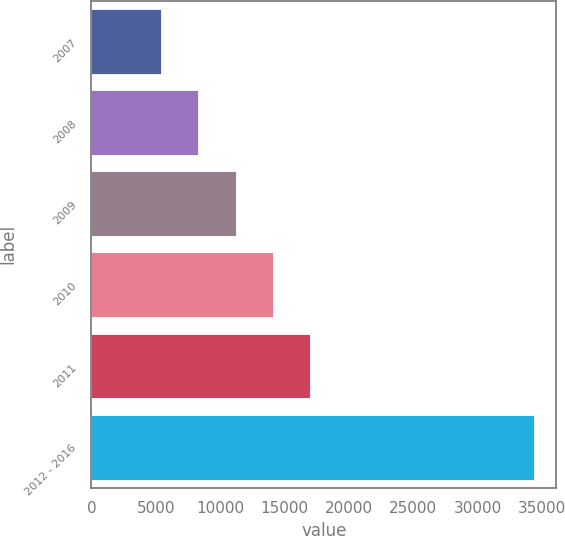Convert chart to OTSL. <chart><loc_0><loc_0><loc_500><loc_500><bar_chart><fcel>2007<fcel>2008<fcel>2009<fcel>2010<fcel>2011<fcel>2012 - 2016<nl><fcel>5423<fcel>8317.5<fcel>11212<fcel>14106.5<fcel>17001<fcel>34368<nl></chart> 